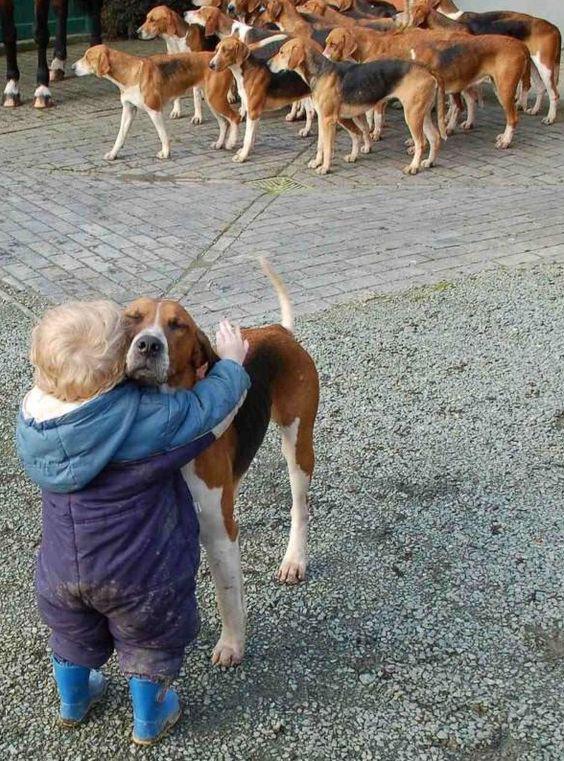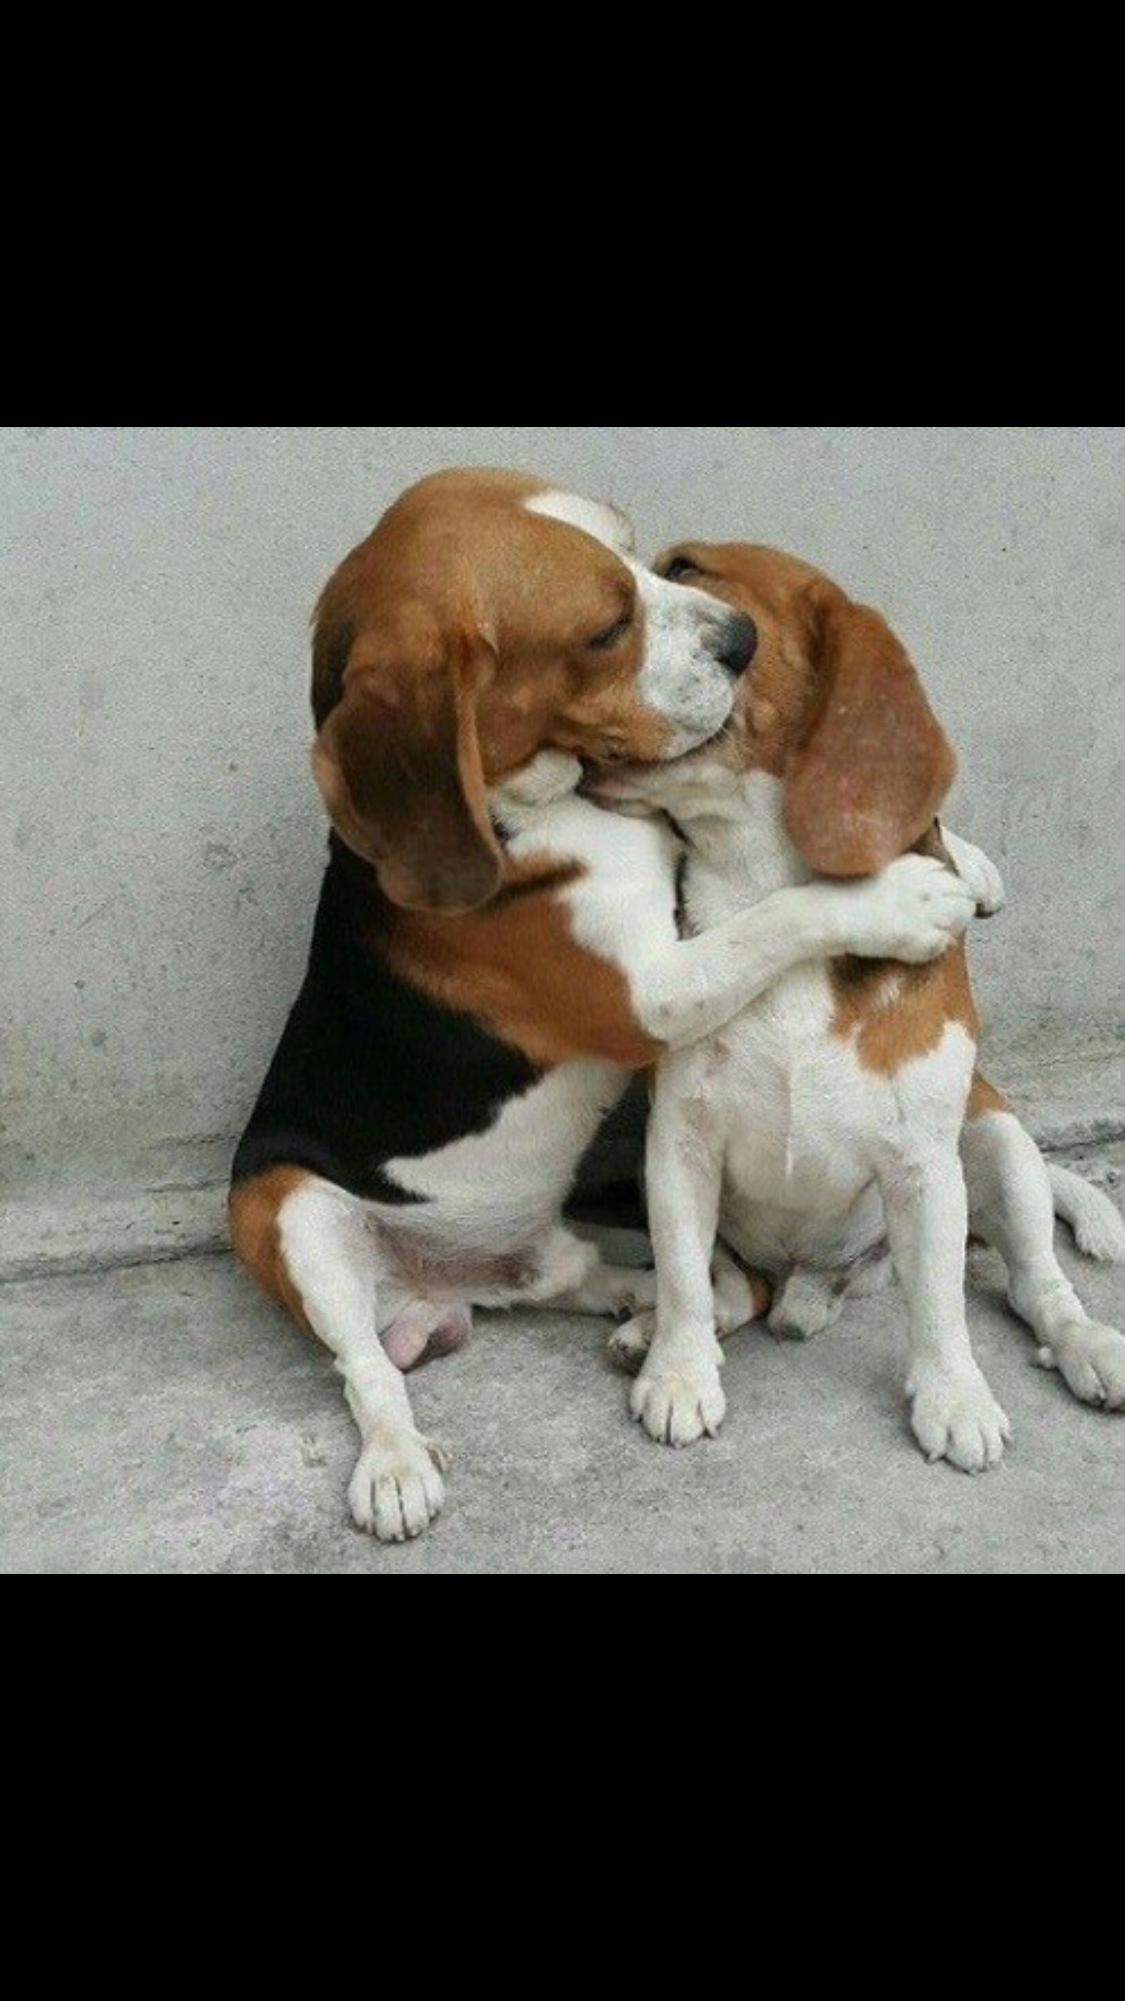The first image is the image on the left, the second image is the image on the right. Assess this claim about the two images: "Some of the dogs are compacted in a group that are all facing to the immediate left.". Correct or not? Answer yes or no. Yes. 